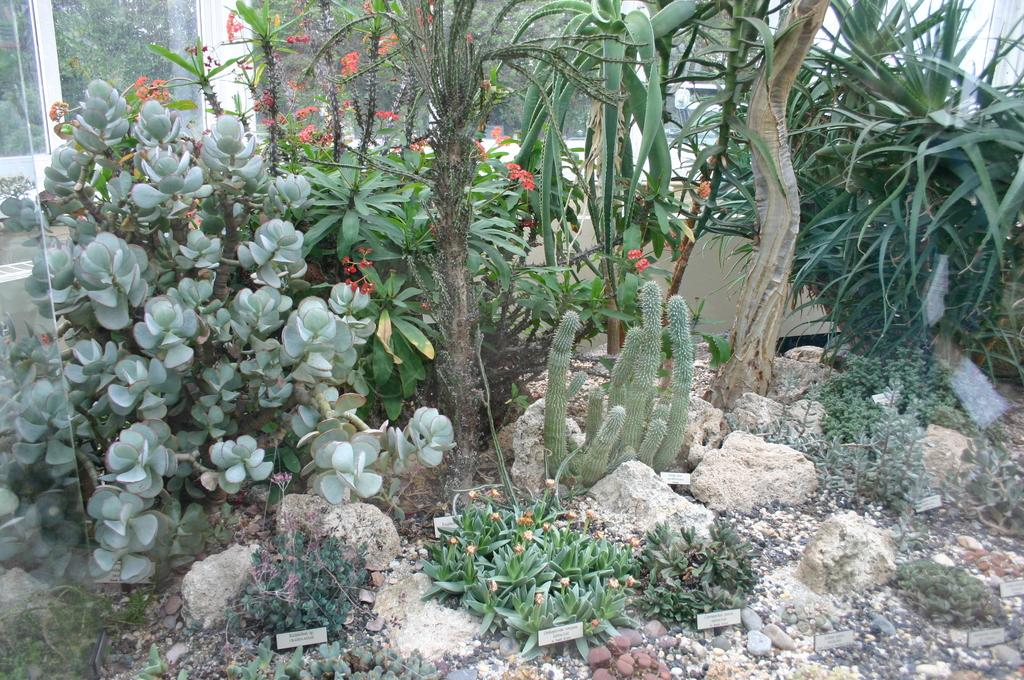What type of living organisms can be seen in the image? Plants can be seen in the image. What other objects are present in the image? There are stones, small name boards, and a glass visible in the image. What can be seen in the background of the image? Trees are visible in the background of the image. Can you see a rabbit hopping around the plants in the image? There is no rabbit present in the image; only plants, stones, small name boards, a glass, and trees are visible. 